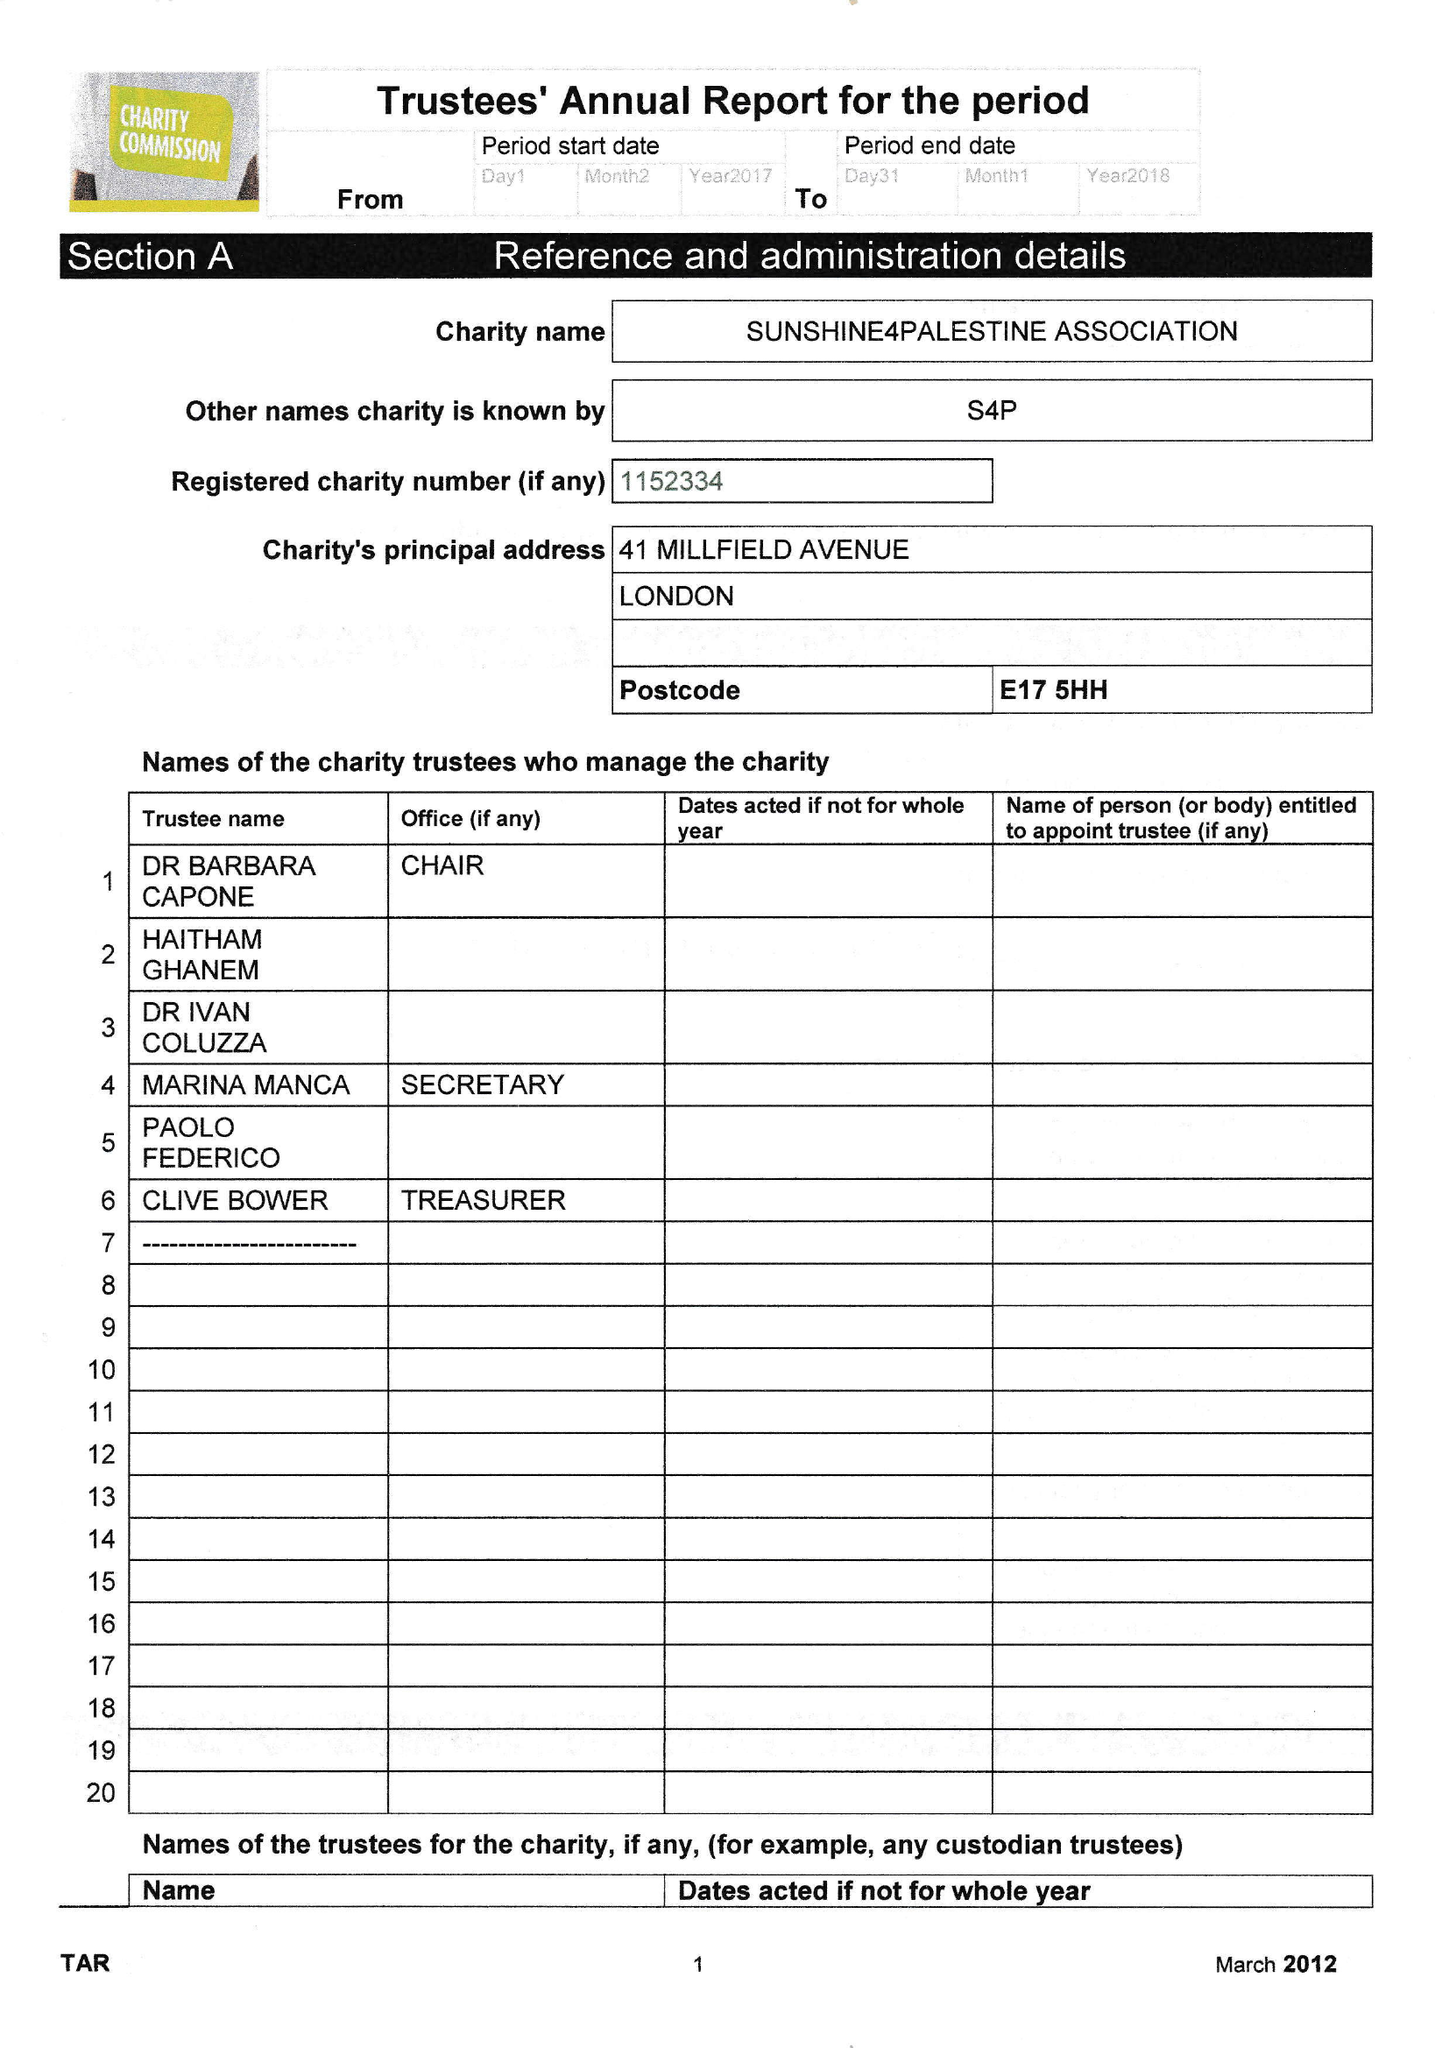What is the value for the report_date?
Answer the question using a single word or phrase. 2018-01-31 